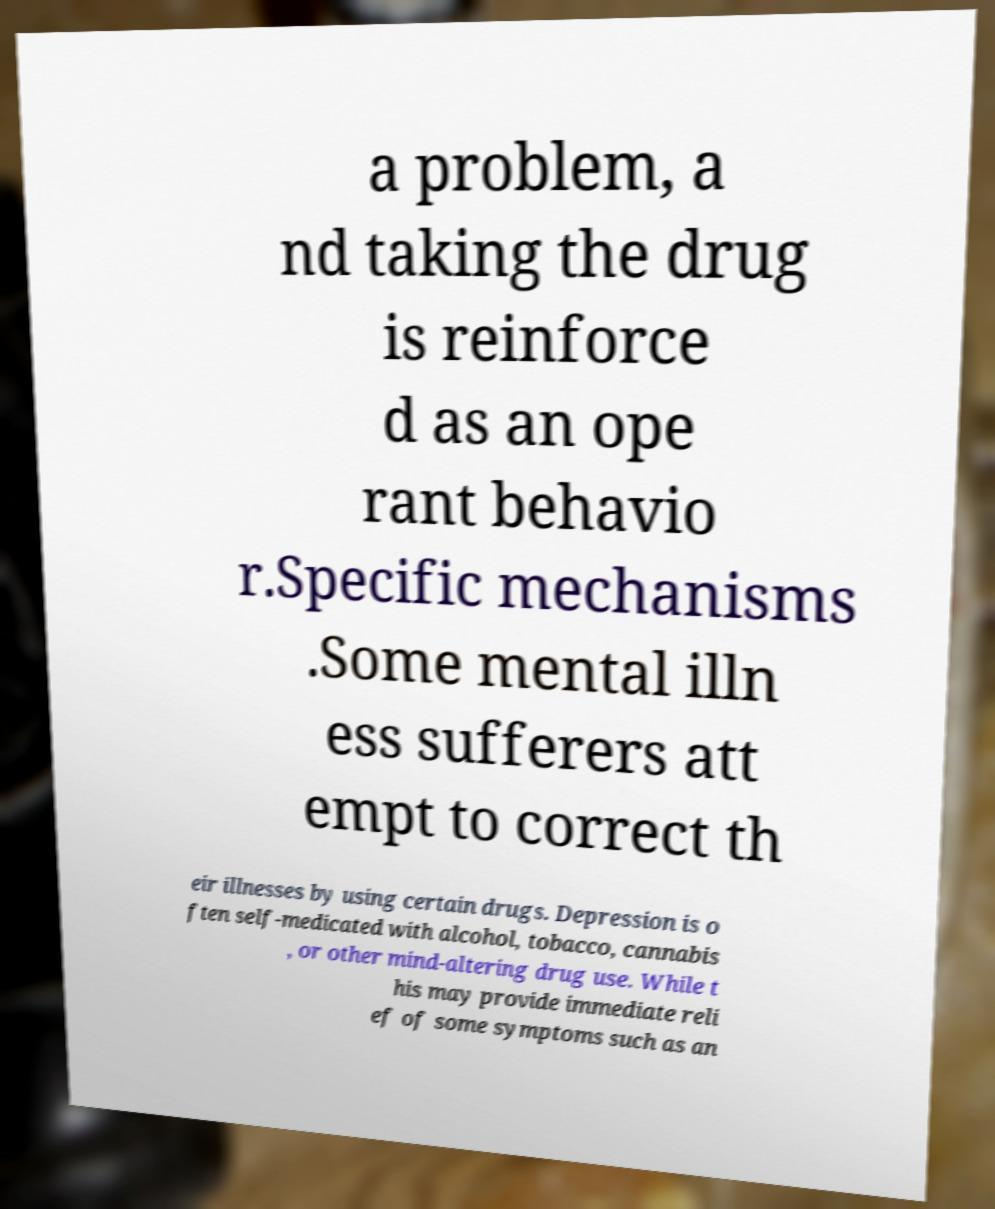Can you read and provide the text displayed in the image?This photo seems to have some interesting text. Can you extract and type it out for me? a problem, a nd taking the drug is reinforce d as an ope rant behavio r.Specific mechanisms .Some mental illn ess sufferers att empt to correct th eir illnesses by using certain drugs. Depression is o ften self-medicated with alcohol, tobacco, cannabis , or other mind-altering drug use. While t his may provide immediate reli ef of some symptoms such as an 